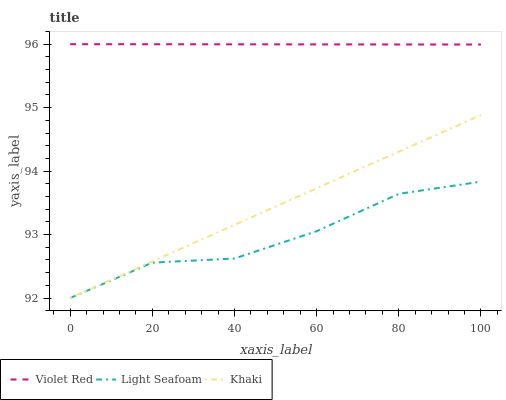Does Khaki have the minimum area under the curve?
Answer yes or no. No. Does Khaki have the maximum area under the curve?
Answer yes or no. No. Is Khaki the smoothest?
Answer yes or no. No. Is Khaki the roughest?
Answer yes or no. No. Does Khaki have the highest value?
Answer yes or no. No. Is Light Seafoam less than Violet Red?
Answer yes or no. Yes. Is Violet Red greater than Khaki?
Answer yes or no. Yes. Does Light Seafoam intersect Violet Red?
Answer yes or no. No. 